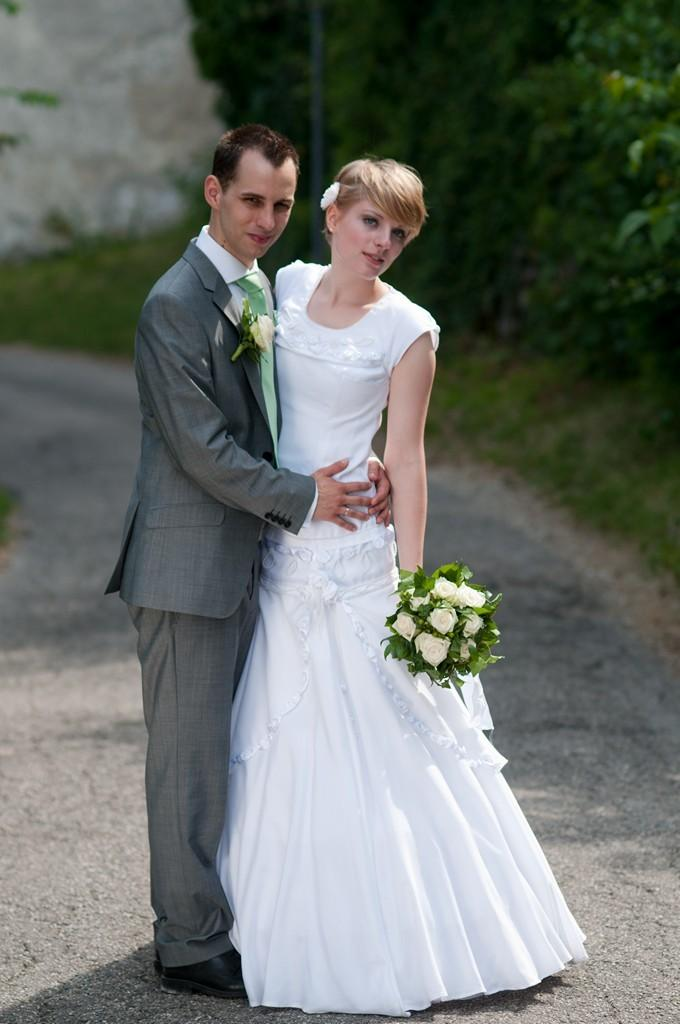What is happening in the image? There is a couple standing in the image. Can you describe the person in the right corner of the image? The person in the right corner is holding a bouquet. What can be seen in the background of the image? There are trees in the background of the image. How many planes are flying over the couple in the image? There are no planes visible in the image. What type of scarf is the duck wearing in the image? There is no duck or scarf present in the image. 